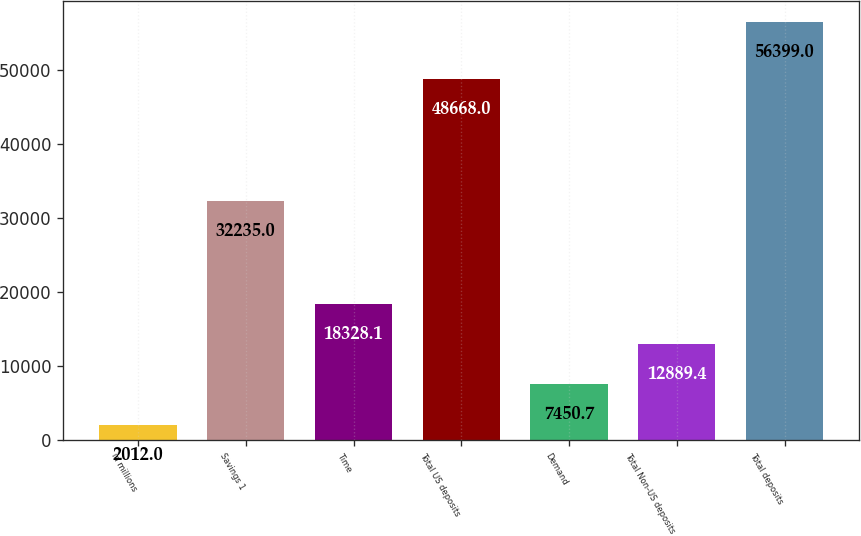<chart> <loc_0><loc_0><loc_500><loc_500><bar_chart><fcel>in millions<fcel>Savings 1<fcel>Time<fcel>Total US deposits<fcel>Demand<fcel>Total Non-US deposits<fcel>Total deposits<nl><fcel>2012<fcel>32235<fcel>18328.1<fcel>48668<fcel>7450.7<fcel>12889.4<fcel>56399<nl></chart> 